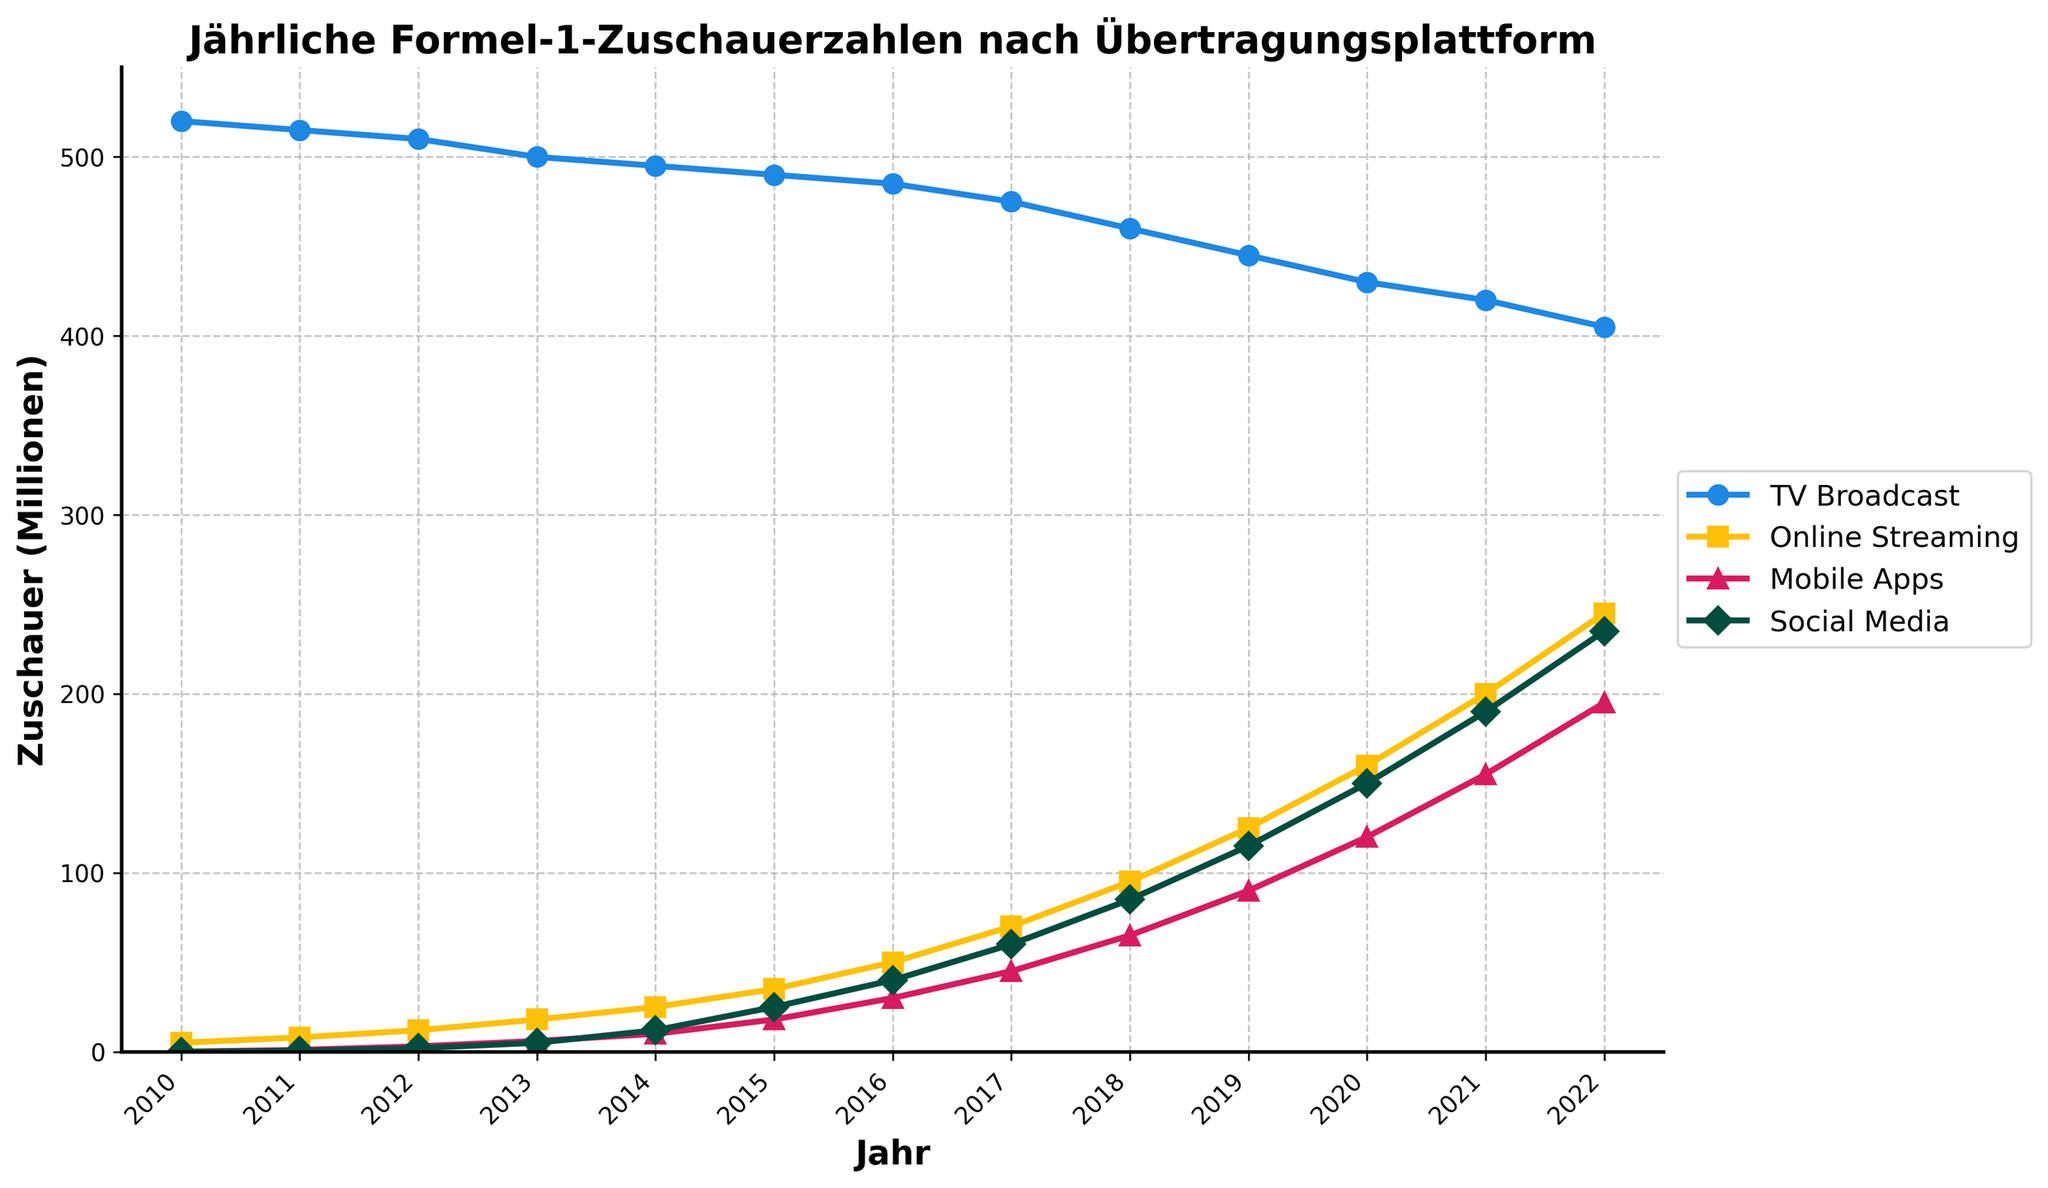What's the trend of TV Broadcast viewership from 2010 to 2022? From the plot, the TV Broadcast viewership shows a steady decline over the years. It starts from 520 million in 2010 and decreases gradually, reaching 405 million in 2022.
Answer: Declining Which year had the highest viewership for Online Streaming? The plot shows that 2022 had the highest viewership for Online Streaming with 245 million viewers.
Answer: 2022 How does Mobile Apps' viewership in 2021 compare to that in 2014? According to the plot, Mobile Apps viewership in 2021 is significantly higher than in 2014. In 2014, it was around 10 million, whereas in 2021, it surged to 155 million.
Answer: 2021 is higher Calculate the total viewership across all platforms in 2018. To calculate the total, add the viewership of each platform for 2018 from the plot: TV Broadcast (460 million) + Online Streaming (95 million) + Mobile Apps (65 million) + Social Media (85 million) = 460 + 95 + 65 + 85 = 705 million.
Answer: 705 million Which platform shows the most consistent year-on-year increase? Based on the plot, Social Media viewership shows a consistent and steep increase every year from 500,000 in 2011 to 235 million in 2022.
Answer: Social Media By how much did Online Streaming viewership increase from 2017 to 2019? From the plot, Online Streaming viewership was 70 million in 2017 and increased to 125 million in 2019. The difference is 125 million - 70 million = 55 million.
Answer: 55 million What is the relative decline in TV Broadcast viewership from 2010 to 2022? The TV Broadcast viewership declined from 520 million in 2010 to 405 million in 2022. The relative decline can be calculated as (520 - 405) / 520 = 115 / 520 ≈ 0.221 or 22.1%.
Answer: 22.1% Which two platforms had the closest viewership numbers in 2020, and what were those numbers? In 2020, the plot shows that Online Streaming had 160 million viewers, and Mobile Apps had 120 million, while Social Media had 150 million. The closest are Social Media (150 million) and Online Streaming (160 million).
Answer: Online Streaming and Social Media, 160 million and 150 million Compare the total viewership of Social Media in 2016 and 2020. Which year was higher and by how much? In 2016, Social Media had 40 million viewers, and in 2020, it reached 150 million. The difference is 150 million - 40 million = 110 million. So, 2020 was higher by 110 million.
Answer: 2020, by 110 million Identify the platform that had exponential growth from its initial year and provide those initial and final viewership figures. Social Media showed exponential growth, starting with 500,000 viewers in 2011 and reaching 235 million in 2022.
Answer: Social Media, from 500,000 to 235 million 